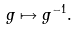<formula> <loc_0><loc_0><loc_500><loc_500>g \mapsto g ^ { - 1 } .</formula> 